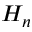Convert formula to latex. <formula><loc_0><loc_0><loc_500><loc_500>H _ { n }</formula> 